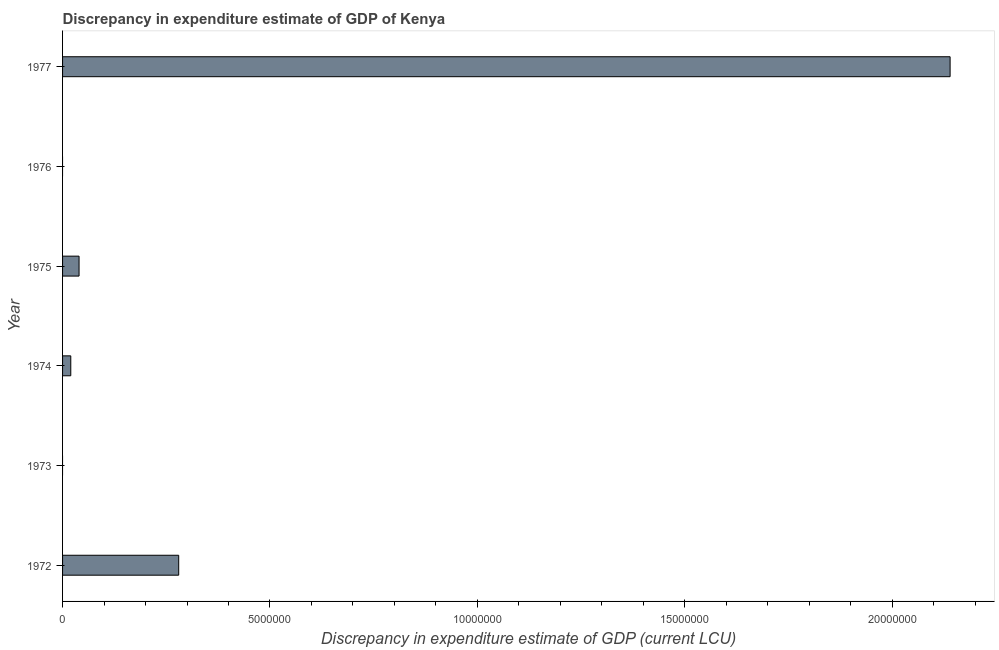Does the graph contain any zero values?
Provide a short and direct response. Yes. Does the graph contain grids?
Offer a terse response. No. What is the title of the graph?
Give a very brief answer. Discrepancy in expenditure estimate of GDP of Kenya. What is the label or title of the X-axis?
Keep it short and to the point. Discrepancy in expenditure estimate of GDP (current LCU). What is the label or title of the Y-axis?
Your response must be concise. Year. What is the discrepancy in expenditure estimate of gdp in 1972?
Keep it short and to the point. 2.80e+06. Across all years, what is the maximum discrepancy in expenditure estimate of gdp?
Your response must be concise. 2.14e+07. In which year was the discrepancy in expenditure estimate of gdp maximum?
Keep it short and to the point. 1977. What is the sum of the discrepancy in expenditure estimate of gdp?
Your answer should be compact. 2.48e+07. What is the difference between the discrepancy in expenditure estimate of gdp in 1974 and 1975?
Your response must be concise. -2.00e+05. What is the average discrepancy in expenditure estimate of gdp per year?
Make the answer very short. 4.13e+06. What is the median discrepancy in expenditure estimate of gdp?
Your response must be concise. 2.98e+05. What is the ratio of the discrepancy in expenditure estimate of gdp in 1975 to that in 1977?
Your answer should be compact. 0.02. Is the difference between the discrepancy in expenditure estimate of gdp in 1972 and 1975 greater than the difference between any two years?
Your response must be concise. No. What is the difference between the highest and the second highest discrepancy in expenditure estimate of gdp?
Provide a succinct answer. 1.86e+07. What is the difference between the highest and the lowest discrepancy in expenditure estimate of gdp?
Provide a short and direct response. 2.14e+07. How many years are there in the graph?
Keep it short and to the point. 6. Are the values on the major ticks of X-axis written in scientific E-notation?
Provide a short and direct response. No. What is the Discrepancy in expenditure estimate of GDP (current LCU) of 1972?
Provide a succinct answer. 2.80e+06. What is the Discrepancy in expenditure estimate of GDP (current LCU) of 1973?
Offer a very short reply. 0. What is the Discrepancy in expenditure estimate of GDP (current LCU) of 1974?
Ensure brevity in your answer.  1.98e+05. What is the Discrepancy in expenditure estimate of GDP (current LCU) in 1975?
Provide a succinct answer. 3.98e+05. What is the Discrepancy in expenditure estimate of GDP (current LCU) in 1977?
Provide a succinct answer. 2.14e+07. What is the difference between the Discrepancy in expenditure estimate of GDP (current LCU) in 1972 and 1974?
Offer a very short reply. 2.60e+06. What is the difference between the Discrepancy in expenditure estimate of GDP (current LCU) in 1972 and 1975?
Your response must be concise. 2.40e+06. What is the difference between the Discrepancy in expenditure estimate of GDP (current LCU) in 1972 and 1977?
Make the answer very short. -1.86e+07. What is the difference between the Discrepancy in expenditure estimate of GDP (current LCU) in 1974 and 1975?
Offer a terse response. -2.00e+05. What is the difference between the Discrepancy in expenditure estimate of GDP (current LCU) in 1974 and 1977?
Offer a terse response. -2.12e+07. What is the difference between the Discrepancy in expenditure estimate of GDP (current LCU) in 1975 and 1977?
Provide a succinct answer. -2.10e+07. What is the ratio of the Discrepancy in expenditure estimate of GDP (current LCU) in 1972 to that in 1974?
Make the answer very short. 14.14. What is the ratio of the Discrepancy in expenditure estimate of GDP (current LCU) in 1972 to that in 1975?
Give a very brief answer. 7.04. What is the ratio of the Discrepancy in expenditure estimate of GDP (current LCU) in 1972 to that in 1977?
Give a very brief answer. 0.13. What is the ratio of the Discrepancy in expenditure estimate of GDP (current LCU) in 1974 to that in 1975?
Your answer should be very brief. 0.5. What is the ratio of the Discrepancy in expenditure estimate of GDP (current LCU) in 1974 to that in 1977?
Your response must be concise. 0.01. What is the ratio of the Discrepancy in expenditure estimate of GDP (current LCU) in 1975 to that in 1977?
Offer a very short reply. 0.02. 